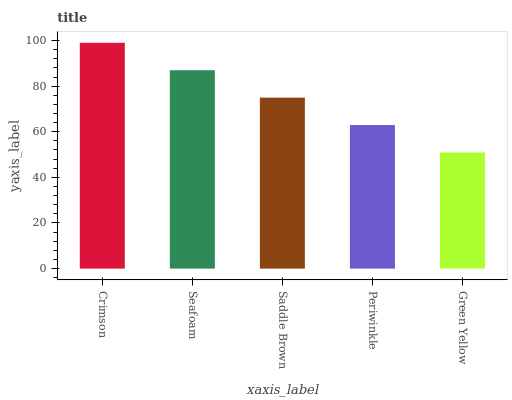Is Green Yellow the minimum?
Answer yes or no. Yes. Is Crimson the maximum?
Answer yes or no. Yes. Is Seafoam the minimum?
Answer yes or no. No. Is Seafoam the maximum?
Answer yes or no. No. Is Crimson greater than Seafoam?
Answer yes or no. Yes. Is Seafoam less than Crimson?
Answer yes or no. Yes. Is Seafoam greater than Crimson?
Answer yes or no. No. Is Crimson less than Seafoam?
Answer yes or no. No. Is Saddle Brown the high median?
Answer yes or no. Yes. Is Saddle Brown the low median?
Answer yes or no. Yes. Is Crimson the high median?
Answer yes or no. No. Is Periwinkle the low median?
Answer yes or no. No. 